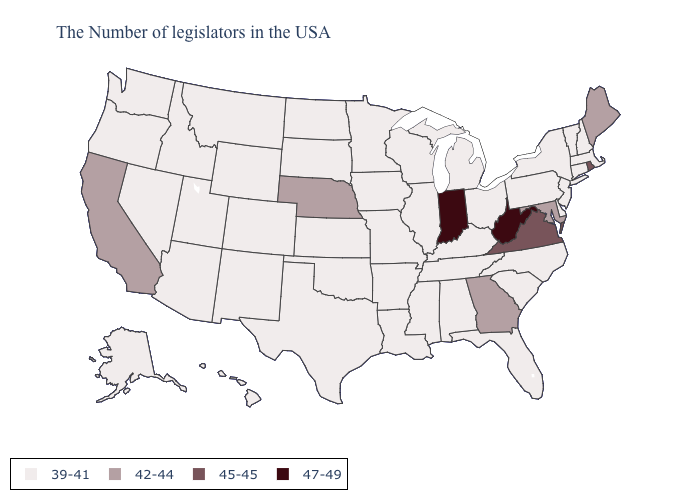What is the value of South Carolina?
Be succinct. 39-41. What is the highest value in the USA?
Answer briefly. 47-49. What is the value of New Mexico?
Be succinct. 39-41. Does Hawaii have the lowest value in the West?
Quick response, please. Yes. Name the states that have a value in the range 45-45?
Be succinct. Rhode Island, Virginia. Does Louisiana have the same value as West Virginia?
Give a very brief answer. No. What is the value of Massachusetts?
Keep it brief. 39-41. Which states have the lowest value in the USA?
Concise answer only. Massachusetts, New Hampshire, Vermont, Connecticut, New York, New Jersey, Delaware, Pennsylvania, North Carolina, South Carolina, Ohio, Florida, Michigan, Kentucky, Alabama, Tennessee, Wisconsin, Illinois, Mississippi, Louisiana, Missouri, Arkansas, Minnesota, Iowa, Kansas, Oklahoma, Texas, South Dakota, North Dakota, Wyoming, Colorado, New Mexico, Utah, Montana, Arizona, Idaho, Nevada, Washington, Oregon, Alaska, Hawaii. What is the lowest value in the West?
Write a very short answer. 39-41. Name the states that have a value in the range 42-44?
Short answer required. Maine, Maryland, Georgia, Nebraska, California. What is the value of Nebraska?
Quick response, please. 42-44. What is the value of Washington?
Short answer required. 39-41. Name the states that have a value in the range 45-45?
Answer briefly. Rhode Island, Virginia. Name the states that have a value in the range 39-41?
Quick response, please. Massachusetts, New Hampshire, Vermont, Connecticut, New York, New Jersey, Delaware, Pennsylvania, North Carolina, South Carolina, Ohio, Florida, Michigan, Kentucky, Alabama, Tennessee, Wisconsin, Illinois, Mississippi, Louisiana, Missouri, Arkansas, Minnesota, Iowa, Kansas, Oklahoma, Texas, South Dakota, North Dakota, Wyoming, Colorado, New Mexico, Utah, Montana, Arizona, Idaho, Nevada, Washington, Oregon, Alaska, Hawaii. How many symbols are there in the legend?
Keep it brief. 4. 